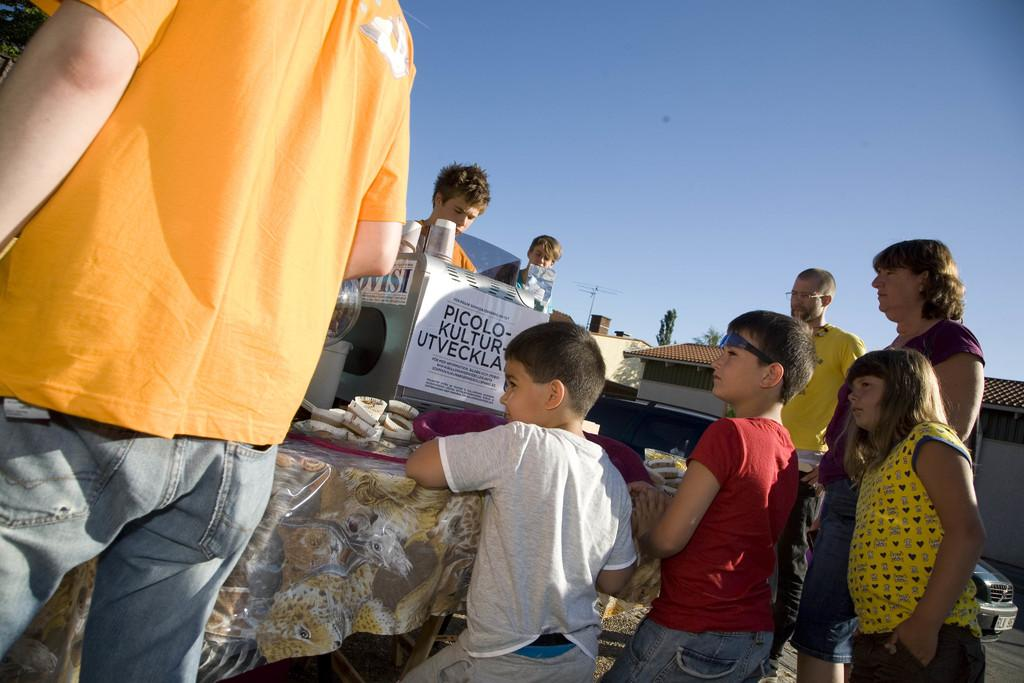How many people are in the group visible in the image? There is a group of people in the image, but the exact number cannot be determined from the provided facts. What is located in front of the group of people? There is a machine in front of the group of people in the image. What can be seen on the table in the image? There are objects on a table in the image. What is visible in the background of the image? There are buildings, trees, and a car in the background of the image. What type of wristwatch is the person wearing in the image? There is no mention of a wristwatch or any person wearing one in the provided facts. How many numbers are visible on the machine in the image? The provided facts do not mention any numbers on the machine, so it is impossible to answer this question. 